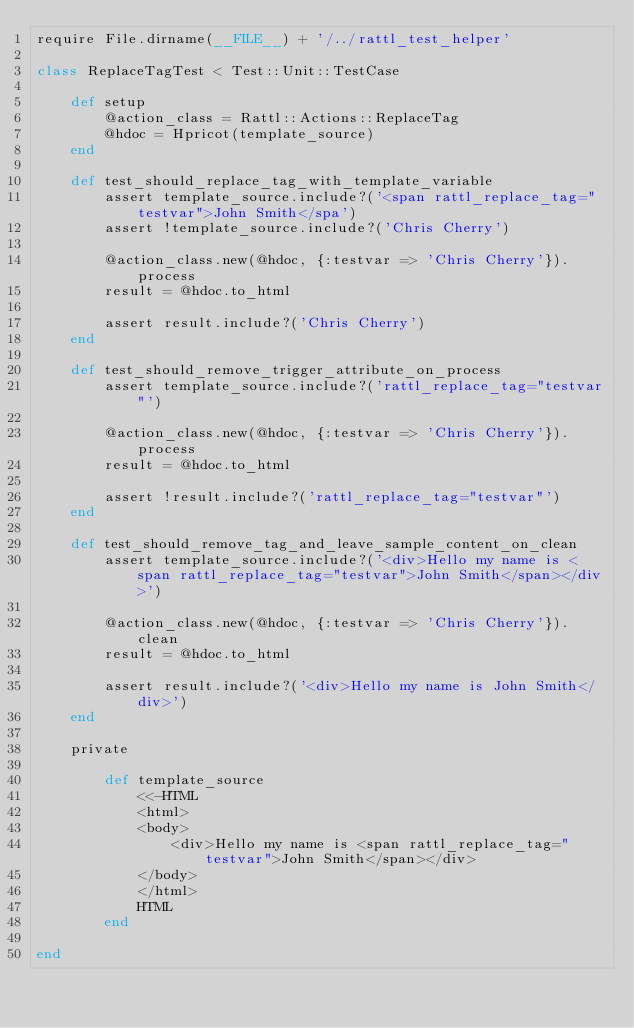Convert code to text. <code><loc_0><loc_0><loc_500><loc_500><_Ruby_>require File.dirname(__FILE__) + '/../rattl_test_helper'

class ReplaceTagTest < Test::Unit::TestCase

	def setup
		@action_class = Rattl::Actions::ReplaceTag
		@hdoc = Hpricot(template_source)
	end
	
	def test_should_replace_tag_with_template_variable
		assert template_source.include?('<span rattl_replace_tag="testvar">John Smith</spa')
		assert !template_source.include?('Chris Cherry')
		
		@action_class.new(@hdoc, {:testvar => 'Chris Cherry'}).process
		result = @hdoc.to_html
		
		assert result.include?('Chris Cherry')
	end
	
	def test_should_remove_trigger_attribute_on_process
		assert template_source.include?('rattl_replace_tag="testvar"')
		
		@action_class.new(@hdoc, {:testvar => 'Chris Cherry'}).process
		result = @hdoc.to_html
		
		assert !result.include?('rattl_replace_tag="testvar"')
	end
	
	def test_should_remove_tag_and_leave_sample_content_on_clean
		assert template_source.include?('<div>Hello my name is <span rattl_replace_tag="testvar">John Smith</span></div>')
		
		@action_class.new(@hdoc, {:testvar => 'Chris Cherry'}).clean
		result = @hdoc.to_html
		
		assert result.include?('<div>Hello my name is John Smith</div>')
	end
	
	private
	
		def template_source
			<<-HTML
			<html>
			<body>
				<div>Hello my name is <span rattl_replace_tag="testvar">John Smith</span></div>
			</body>
			</html>
			HTML
		end
	
end</code> 